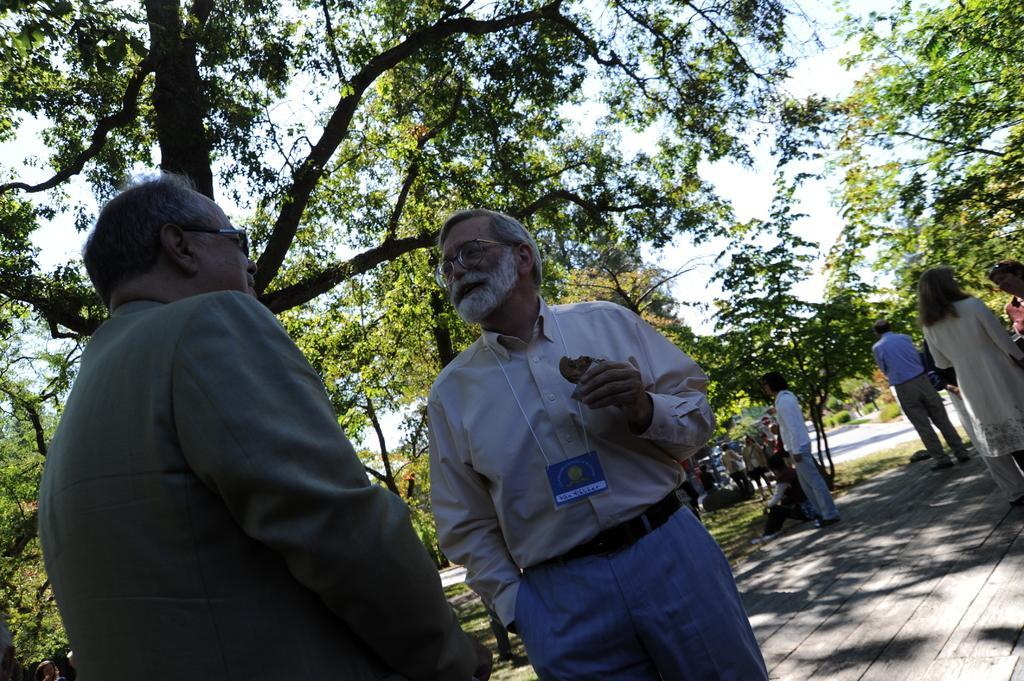How would you summarize this image in a sentence or two? In the picture I can see people are on the road, around we can see some trees and grass. 